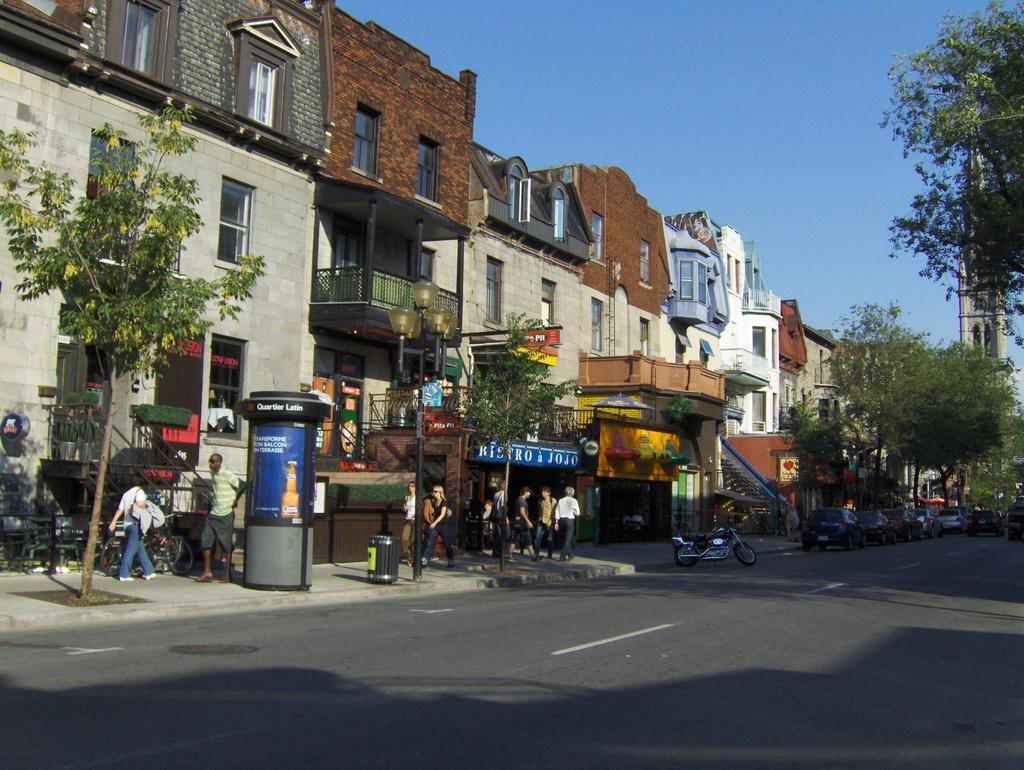Could you give a brief overview of what you see in this image? In this image I can see on the left side few people are walking on the footpath, there are buildings. On the right side there are trees, at the top it is the sky, at the bottom it is the road. 